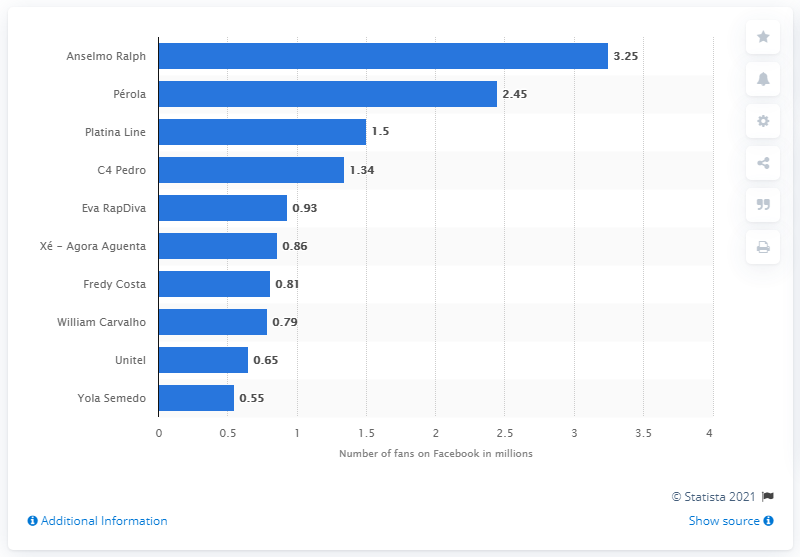Identify some key points in this picture. Anselmo Ralph was the most popular Facebook page in Angola in January 2021. The number of Facebook fans that Anselmo Ralph had worldwide was 3.25. 